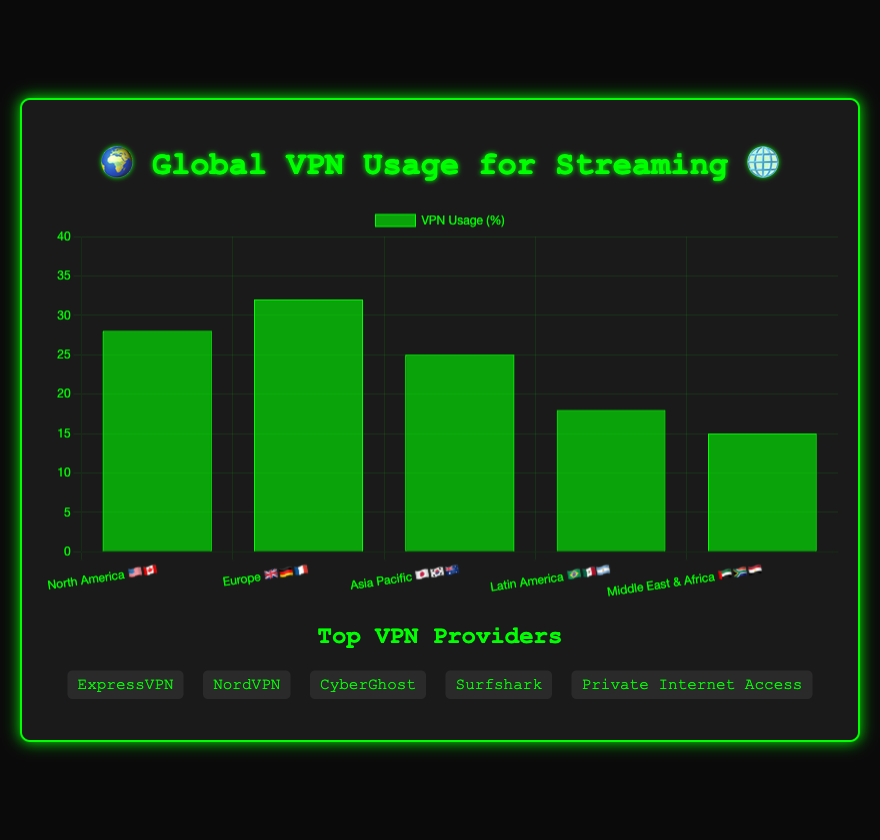How many regions are displayed on the chart? The chart displays the 'Global distribution of VPN usage for accessing geo-restricted streaming content', and lists regions with labels 'North America 🇺🇸🇨🇦', 'Europe 🇬🇧🇩🇪🇫🇷', 'Asia Pacific 🇯🇵🇰🇷🇦🇺', 'Latin America 🇧🇷🇲🇽🇦🇷', 'Middle East & Africa 🇦🇪🇿🇦🇪🇬'. Count each region.
Answer: 5 Which region has the highest VPN usage percentage? The chart shows the VPN usage percentages for each region. By observing the heights of the bars, 'Europe 🇬🇧🇩🇪🇫🇷' has the highest percentage at 32%.
Answer: Europe 🇬🇧🇩🇪🇫🇷 Compare VPN usage percentage between North America and Latin America. Which one is higher and by how much? The chart displays VPN usage percentages for 'North America 🇺🇸🇨🇦' as 28% and 'Latin America 🇧🇷🇲🇽🇦🇷' as 18%. To find out which is higher and by how much, subtract the smaller value from the larger value: 28% - 18% = 10%. North America has a higher usage by 10%.
Answer: North America by 10% What is the combined VPN usage percentage of Asia Pacific and Middle East & Africa? The chart shows 'Asia Pacific 🇯🇵🇰🇷🇦🇺' with 25% and 'Middle East & Africa 🇦🇪🇿🇦🇪🇬' with 15%. To find the combined percentage, sum these two values: 25% + 15% = 40%.
Answer: 40% Which region has the lowest VPN usage percentage, and what does this percentage represent? By observing the heights of the bars in the chart, 'Middle East & Africa 🇦🇪🇿🇦🇪🇬' has the lowest VPN usage at 15%. This signifies the smallest proportion of users accessing geo-restricted content via VPN in this region.
Answer: Middle East & Africa, 15% List the popular streaming services for Europe. The chart has a tooltip that shows 'Popular Services' for each region. For 'Europe 🇬🇧🇩🇪🇫🇷', the popular streaming services listed are 'BBC iPlayer', 'Sky Go', 'DAZN'.
Answer: BBC iPlayer, Sky Go, DAZN What is the average VPN usage percentage across all regions? First, note the VPN usage percentages from the chart: North America 28%, Europe 32%, Asia Pacific 25%, Latin America 18%, Middle East & Africa 15%. Add these values together: 28 + 32 + 25 + 18 + 15 = 118. Divide this sum by the number of regions (5): 118 / 5 = 23.6%.
Answer: 23.6% Which region is represented by the emoji combination 🇧🇷🇲🇽🇦🇷 and what is its VPN usage percentage? The combination 🇧🇷🇲🇽🇦🇷 corresponds to 'Latin America'. The chart shows that 'Latin America' has a VPN usage percentage of 18%.
Answer: Latin America, 18% Name the top VPN providers mentioned in the chart. The chart lists the 'Top VPN Providers' in a separate section at the bottom. The providers are 'ExpressVPN', 'NordVPN', 'CyberGhost', 'Surfshark', and 'Private Internet Access'.
Answer: ExpressVPN, NordVPN, CyberGhost, Surfshark, Private Internet Access If the total percentage available is 100%, how much percentage of VPN usage is not accounted for by the highest-usage region (Europe)? The maximum overall percentage is 100%. Since Europe has 32% VPN usage, subtract this from 100 to find the remaining percentage: 100% - 32% = 68%.
Answer: 68% 